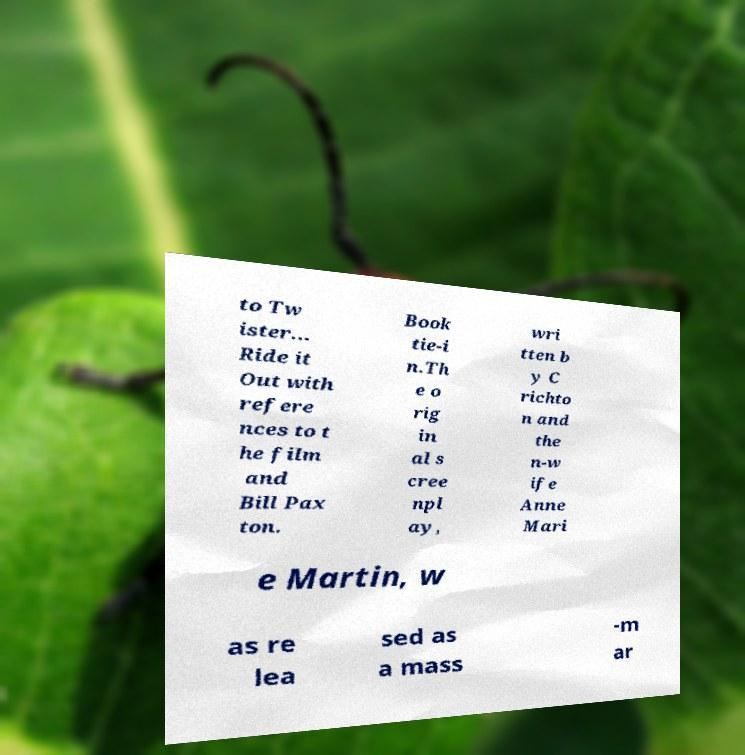For documentation purposes, I need the text within this image transcribed. Could you provide that? to Tw ister... Ride it Out with refere nces to t he film and Bill Pax ton. Book tie-i n.Th e o rig in al s cree npl ay, wri tten b y C richto n and the n-w ife Anne Mari e Martin, w as re lea sed as a mass -m ar 